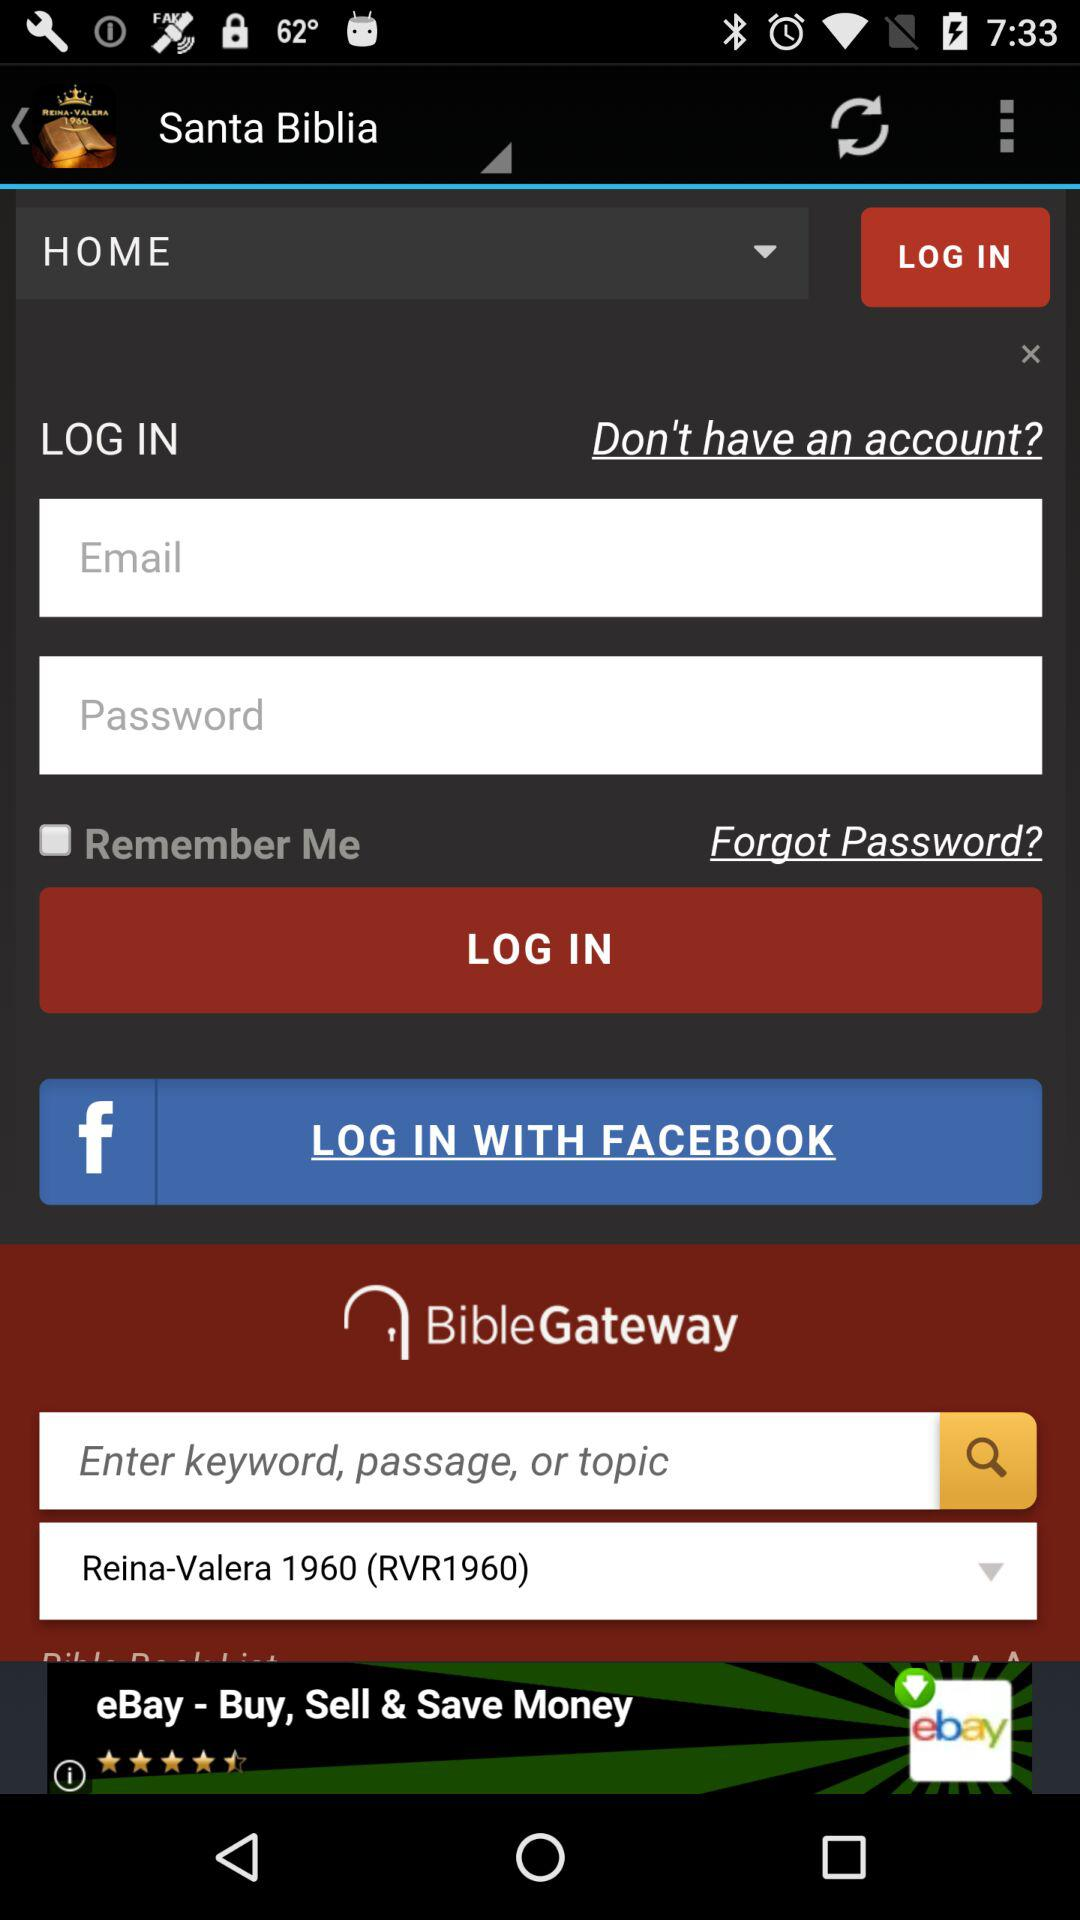Can we reset password?
When the provided information is insufficient, respond with <no answer>. <no answer> 